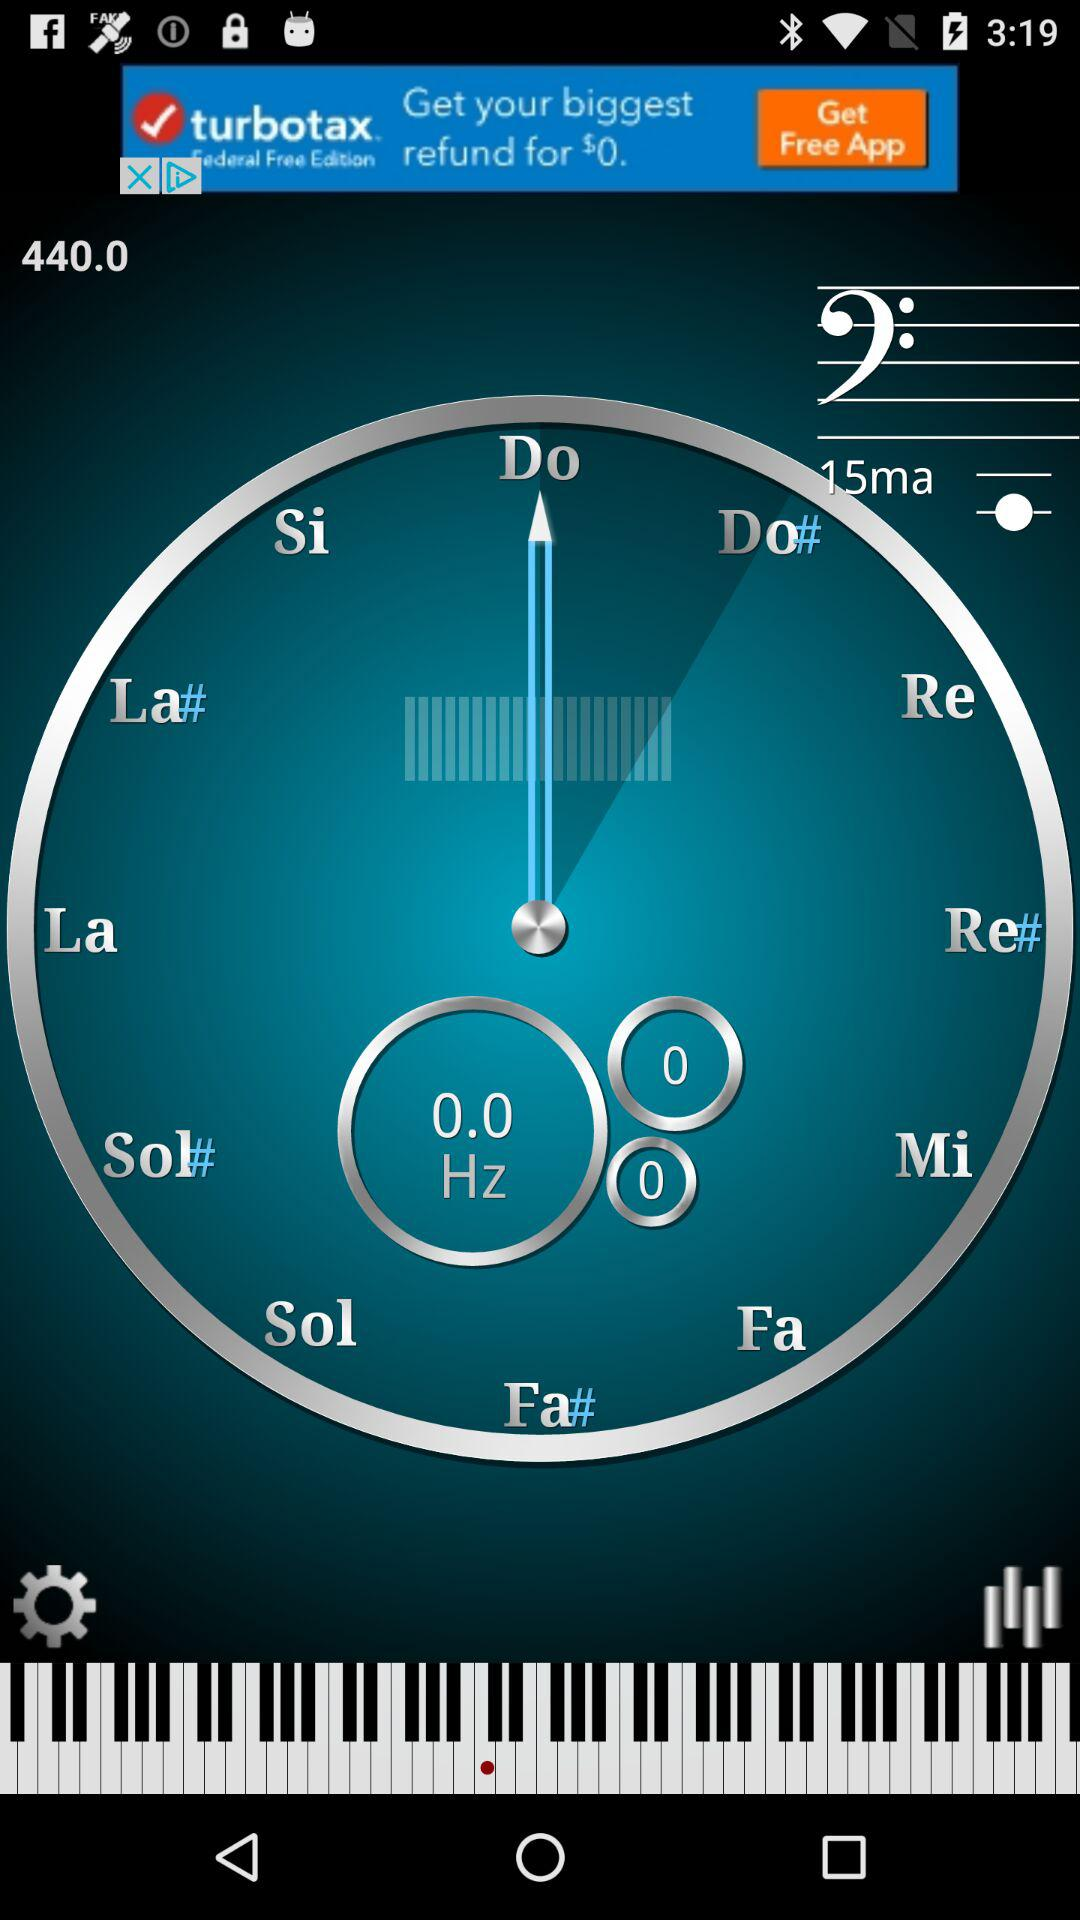What is the shown frequency? The shown frequency is 0 Hz. 